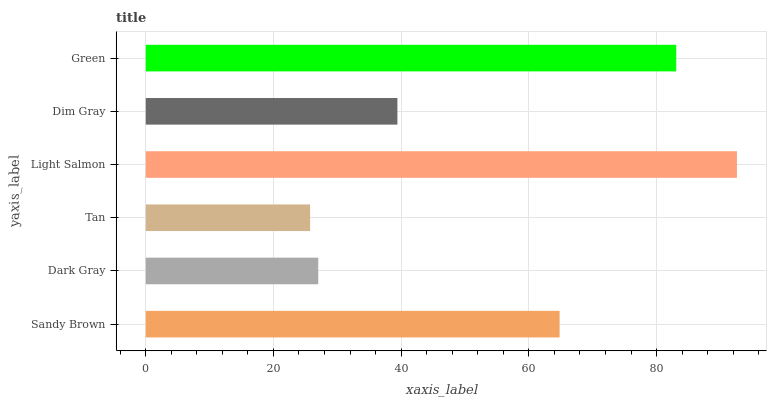Is Tan the minimum?
Answer yes or no. Yes. Is Light Salmon the maximum?
Answer yes or no. Yes. Is Dark Gray the minimum?
Answer yes or no. No. Is Dark Gray the maximum?
Answer yes or no. No. Is Sandy Brown greater than Dark Gray?
Answer yes or no. Yes. Is Dark Gray less than Sandy Brown?
Answer yes or no. Yes. Is Dark Gray greater than Sandy Brown?
Answer yes or no. No. Is Sandy Brown less than Dark Gray?
Answer yes or no. No. Is Sandy Brown the high median?
Answer yes or no. Yes. Is Dim Gray the low median?
Answer yes or no. Yes. Is Tan the high median?
Answer yes or no. No. Is Tan the low median?
Answer yes or no. No. 